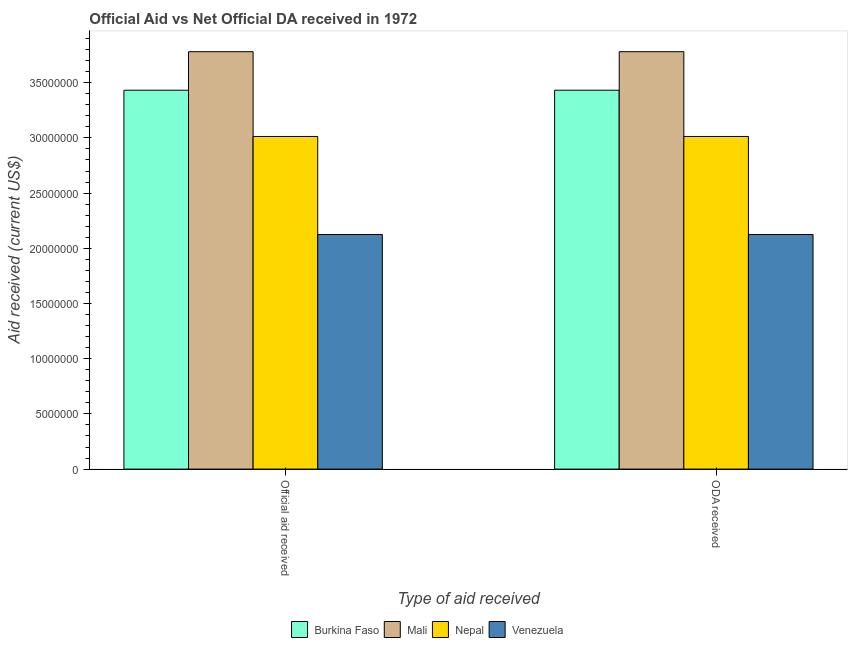How many bars are there on the 1st tick from the right?
Provide a succinct answer. 4. What is the label of the 2nd group of bars from the left?
Give a very brief answer. ODA received. What is the oda received in Nepal?
Make the answer very short. 3.01e+07. Across all countries, what is the maximum oda received?
Your answer should be very brief. 3.78e+07. Across all countries, what is the minimum oda received?
Your answer should be very brief. 2.12e+07. In which country was the oda received maximum?
Ensure brevity in your answer.  Mali. In which country was the oda received minimum?
Your response must be concise. Venezuela. What is the total official aid received in the graph?
Make the answer very short. 1.24e+08. What is the difference between the official aid received in Nepal and that in Venezuela?
Offer a terse response. 8.88e+06. What is the difference between the oda received in Nepal and the official aid received in Mali?
Your response must be concise. -7.68e+06. What is the average official aid received per country?
Provide a succinct answer. 3.09e+07. What is the difference between the oda received and official aid received in Nepal?
Keep it short and to the point. 0. In how many countries, is the official aid received greater than 35000000 US$?
Your answer should be compact. 1. What is the ratio of the official aid received in Nepal to that in Burkina Faso?
Give a very brief answer. 0.88. What does the 3rd bar from the left in ODA received represents?
Make the answer very short. Nepal. What does the 4th bar from the right in ODA received represents?
Keep it short and to the point. Burkina Faso. How many countries are there in the graph?
Your response must be concise. 4. What is the difference between two consecutive major ticks on the Y-axis?
Give a very brief answer. 5.00e+06. Does the graph contain grids?
Your answer should be compact. No. What is the title of the graph?
Offer a terse response. Official Aid vs Net Official DA received in 1972 . Does "Portugal" appear as one of the legend labels in the graph?
Provide a short and direct response. No. What is the label or title of the X-axis?
Your response must be concise. Type of aid received. What is the label or title of the Y-axis?
Keep it short and to the point. Aid received (current US$). What is the Aid received (current US$) in Burkina Faso in Official aid received?
Your answer should be compact. 3.43e+07. What is the Aid received (current US$) in Mali in Official aid received?
Offer a terse response. 3.78e+07. What is the Aid received (current US$) in Nepal in Official aid received?
Provide a short and direct response. 3.01e+07. What is the Aid received (current US$) in Venezuela in Official aid received?
Give a very brief answer. 2.12e+07. What is the Aid received (current US$) in Burkina Faso in ODA received?
Give a very brief answer. 3.43e+07. What is the Aid received (current US$) in Mali in ODA received?
Provide a short and direct response. 3.78e+07. What is the Aid received (current US$) in Nepal in ODA received?
Provide a succinct answer. 3.01e+07. What is the Aid received (current US$) in Venezuela in ODA received?
Provide a short and direct response. 2.12e+07. Across all Type of aid received, what is the maximum Aid received (current US$) of Burkina Faso?
Offer a very short reply. 3.43e+07. Across all Type of aid received, what is the maximum Aid received (current US$) in Mali?
Offer a very short reply. 3.78e+07. Across all Type of aid received, what is the maximum Aid received (current US$) in Nepal?
Your answer should be compact. 3.01e+07. Across all Type of aid received, what is the maximum Aid received (current US$) in Venezuela?
Make the answer very short. 2.12e+07. Across all Type of aid received, what is the minimum Aid received (current US$) in Burkina Faso?
Your response must be concise. 3.43e+07. Across all Type of aid received, what is the minimum Aid received (current US$) in Mali?
Your answer should be very brief. 3.78e+07. Across all Type of aid received, what is the minimum Aid received (current US$) of Nepal?
Ensure brevity in your answer.  3.01e+07. Across all Type of aid received, what is the minimum Aid received (current US$) of Venezuela?
Make the answer very short. 2.12e+07. What is the total Aid received (current US$) of Burkina Faso in the graph?
Your answer should be very brief. 6.86e+07. What is the total Aid received (current US$) in Mali in the graph?
Offer a terse response. 7.56e+07. What is the total Aid received (current US$) in Nepal in the graph?
Offer a terse response. 6.03e+07. What is the total Aid received (current US$) in Venezuela in the graph?
Provide a short and direct response. 4.25e+07. What is the difference between the Aid received (current US$) in Mali in Official aid received and that in ODA received?
Offer a very short reply. 0. What is the difference between the Aid received (current US$) of Burkina Faso in Official aid received and the Aid received (current US$) of Mali in ODA received?
Give a very brief answer. -3.49e+06. What is the difference between the Aid received (current US$) in Burkina Faso in Official aid received and the Aid received (current US$) in Nepal in ODA received?
Provide a succinct answer. 4.19e+06. What is the difference between the Aid received (current US$) of Burkina Faso in Official aid received and the Aid received (current US$) of Venezuela in ODA received?
Your answer should be very brief. 1.31e+07. What is the difference between the Aid received (current US$) of Mali in Official aid received and the Aid received (current US$) of Nepal in ODA received?
Your answer should be compact. 7.68e+06. What is the difference between the Aid received (current US$) of Mali in Official aid received and the Aid received (current US$) of Venezuela in ODA received?
Your answer should be compact. 1.66e+07. What is the difference between the Aid received (current US$) in Nepal in Official aid received and the Aid received (current US$) in Venezuela in ODA received?
Provide a succinct answer. 8.88e+06. What is the average Aid received (current US$) in Burkina Faso per Type of aid received?
Your answer should be compact. 3.43e+07. What is the average Aid received (current US$) of Mali per Type of aid received?
Provide a short and direct response. 3.78e+07. What is the average Aid received (current US$) of Nepal per Type of aid received?
Offer a terse response. 3.01e+07. What is the average Aid received (current US$) in Venezuela per Type of aid received?
Provide a succinct answer. 2.12e+07. What is the difference between the Aid received (current US$) of Burkina Faso and Aid received (current US$) of Mali in Official aid received?
Keep it short and to the point. -3.49e+06. What is the difference between the Aid received (current US$) of Burkina Faso and Aid received (current US$) of Nepal in Official aid received?
Make the answer very short. 4.19e+06. What is the difference between the Aid received (current US$) in Burkina Faso and Aid received (current US$) in Venezuela in Official aid received?
Your answer should be compact. 1.31e+07. What is the difference between the Aid received (current US$) in Mali and Aid received (current US$) in Nepal in Official aid received?
Your response must be concise. 7.68e+06. What is the difference between the Aid received (current US$) in Mali and Aid received (current US$) in Venezuela in Official aid received?
Your answer should be very brief. 1.66e+07. What is the difference between the Aid received (current US$) in Nepal and Aid received (current US$) in Venezuela in Official aid received?
Your response must be concise. 8.88e+06. What is the difference between the Aid received (current US$) of Burkina Faso and Aid received (current US$) of Mali in ODA received?
Your response must be concise. -3.49e+06. What is the difference between the Aid received (current US$) in Burkina Faso and Aid received (current US$) in Nepal in ODA received?
Your answer should be compact. 4.19e+06. What is the difference between the Aid received (current US$) of Burkina Faso and Aid received (current US$) of Venezuela in ODA received?
Offer a terse response. 1.31e+07. What is the difference between the Aid received (current US$) in Mali and Aid received (current US$) in Nepal in ODA received?
Provide a short and direct response. 7.68e+06. What is the difference between the Aid received (current US$) in Mali and Aid received (current US$) in Venezuela in ODA received?
Provide a succinct answer. 1.66e+07. What is the difference between the Aid received (current US$) in Nepal and Aid received (current US$) in Venezuela in ODA received?
Offer a terse response. 8.88e+06. What is the ratio of the Aid received (current US$) in Burkina Faso in Official aid received to that in ODA received?
Give a very brief answer. 1. What is the ratio of the Aid received (current US$) of Nepal in Official aid received to that in ODA received?
Offer a terse response. 1. What is the ratio of the Aid received (current US$) of Venezuela in Official aid received to that in ODA received?
Your answer should be compact. 1. What is the difference between the highest and the second highest Aid received (current US$) of Nepal?
Make the answer very short. 0. What is the difference between the highest and the second highest Aid received (current US$) of Venezuela?
Offer a terse response. 0. What is the difference between the highest and the lowest Aid received (current US$) of Nepal?
Provide a succinct answer. 0. 